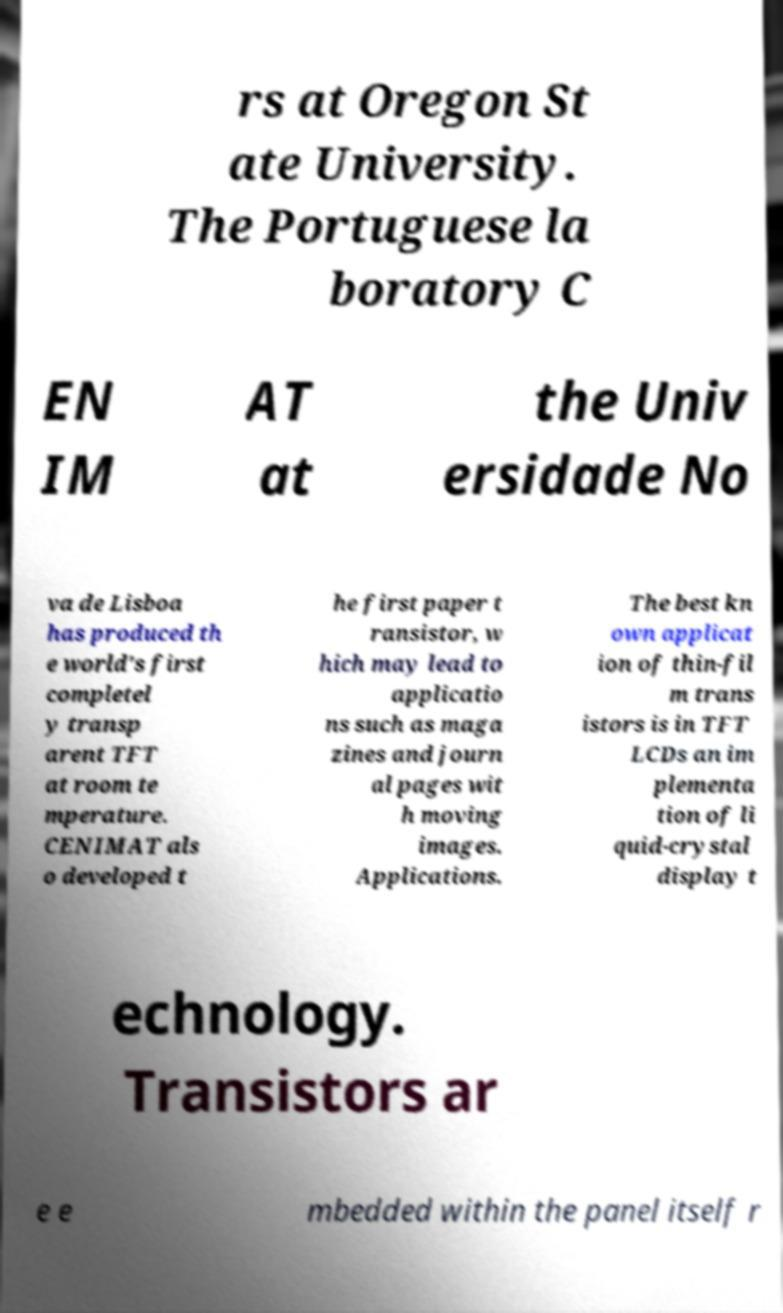Could you assist in decoding the text presented in this image and type it out clearly? rs at Oregon St ate University. The Portuguese la boratory C EN IM AT at the Univ ersidade No va de Lisboa has produced th e world's first completel y transp arent TFT at room te mperature. CENIMAT als o developed t he first paper t ransistor, w hich may lead to applicatio ns such as maga zines and journ al pages wit h moving images. Applications. The best kn own applicat ion of thin-fil m trans istors is in TFT LCDs an im plementa tion of li quid-crystal display t echnology. Transistors ar e e mbedded within the panel itself r 